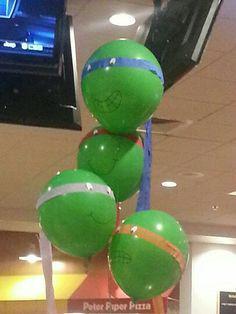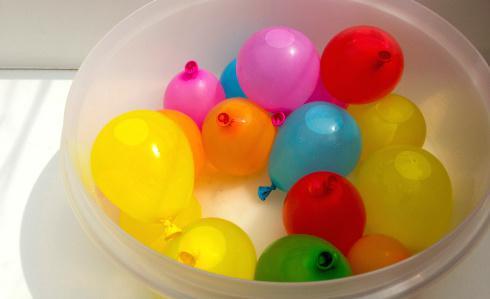The first image is the image on the left, the second image is the image on the right. Evaluate the accuracy of this statement regarding the images: "Some balloons have helium in them.". Is it true? Answer yes or no. Yes. The first image is the image on the left, the second image is the image on the right. For the images displayed, is the sentence "Several balloons are in the air in the left image, and at least a dozen balloons are in a container with sides in the right image." factually correct? Answer yes or no. Yes. 